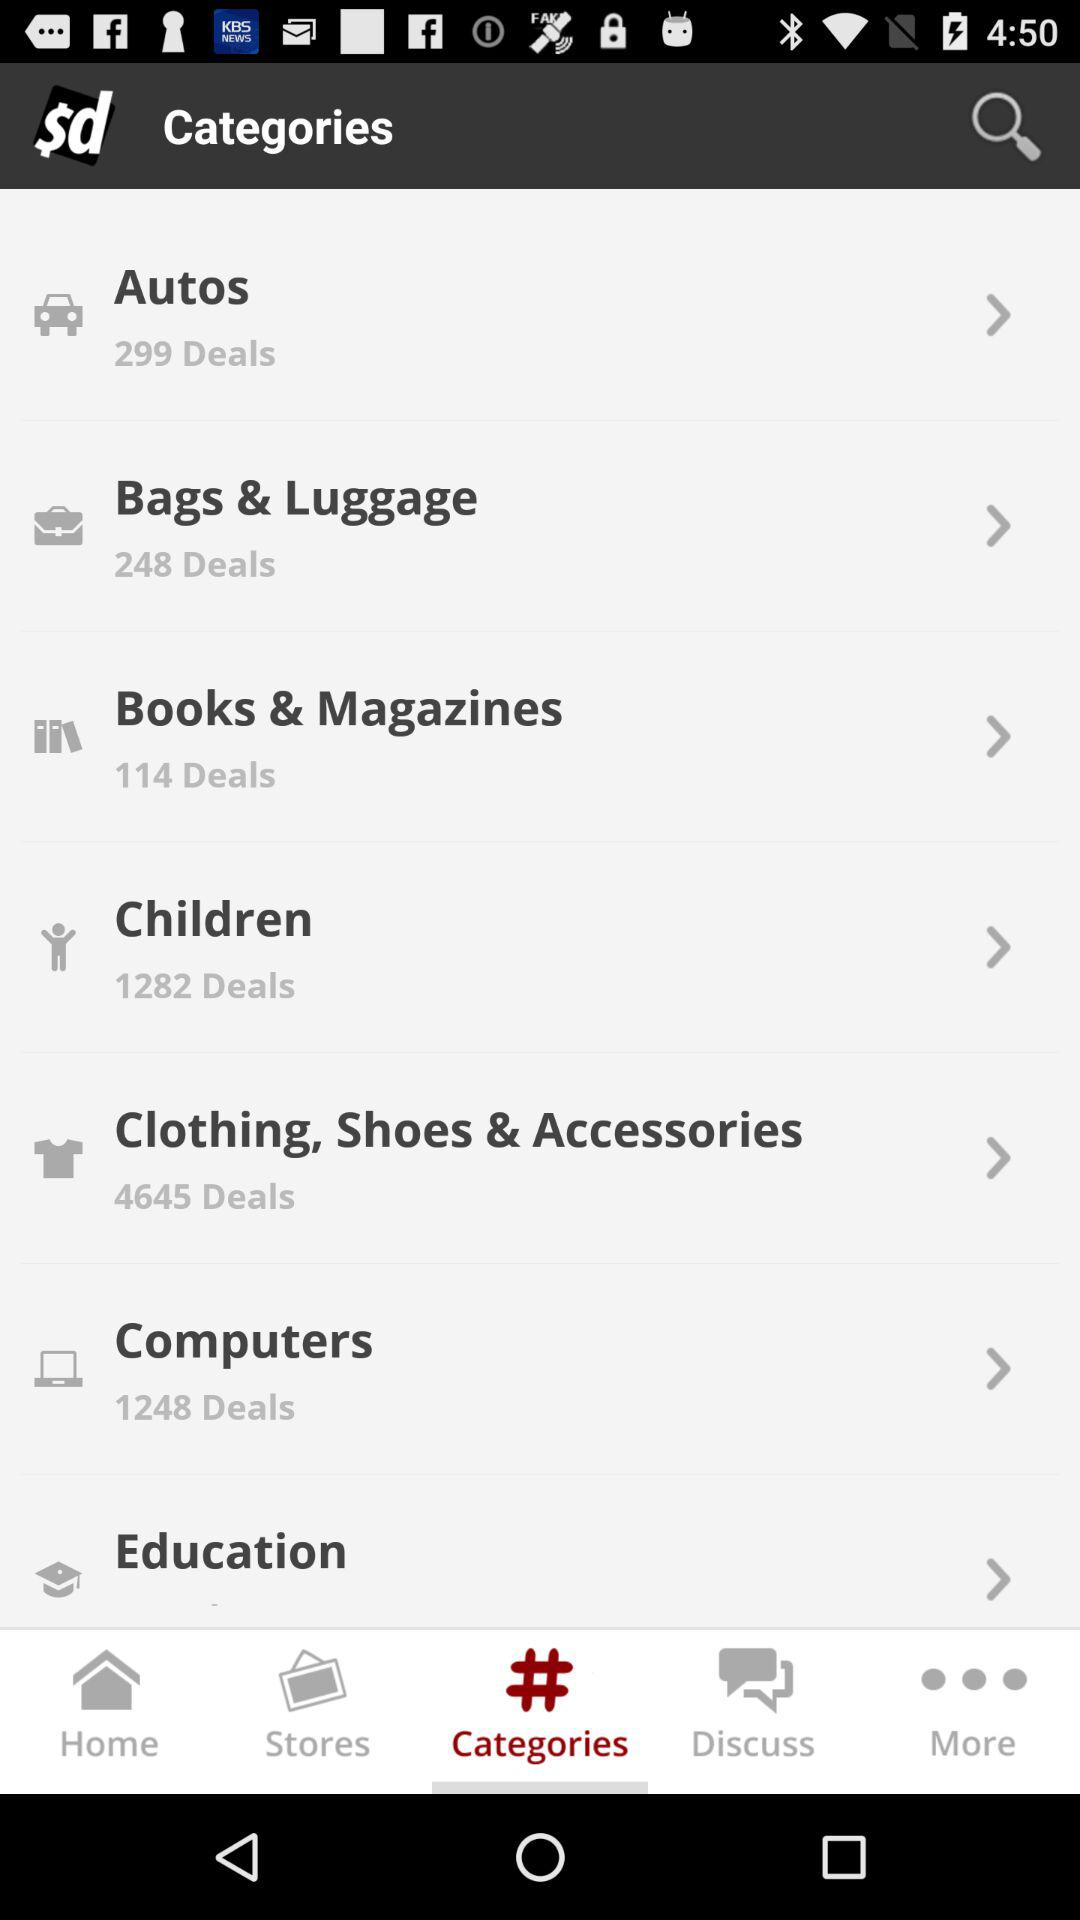How many deals are there in "Computers"? There are 1248 deals. 